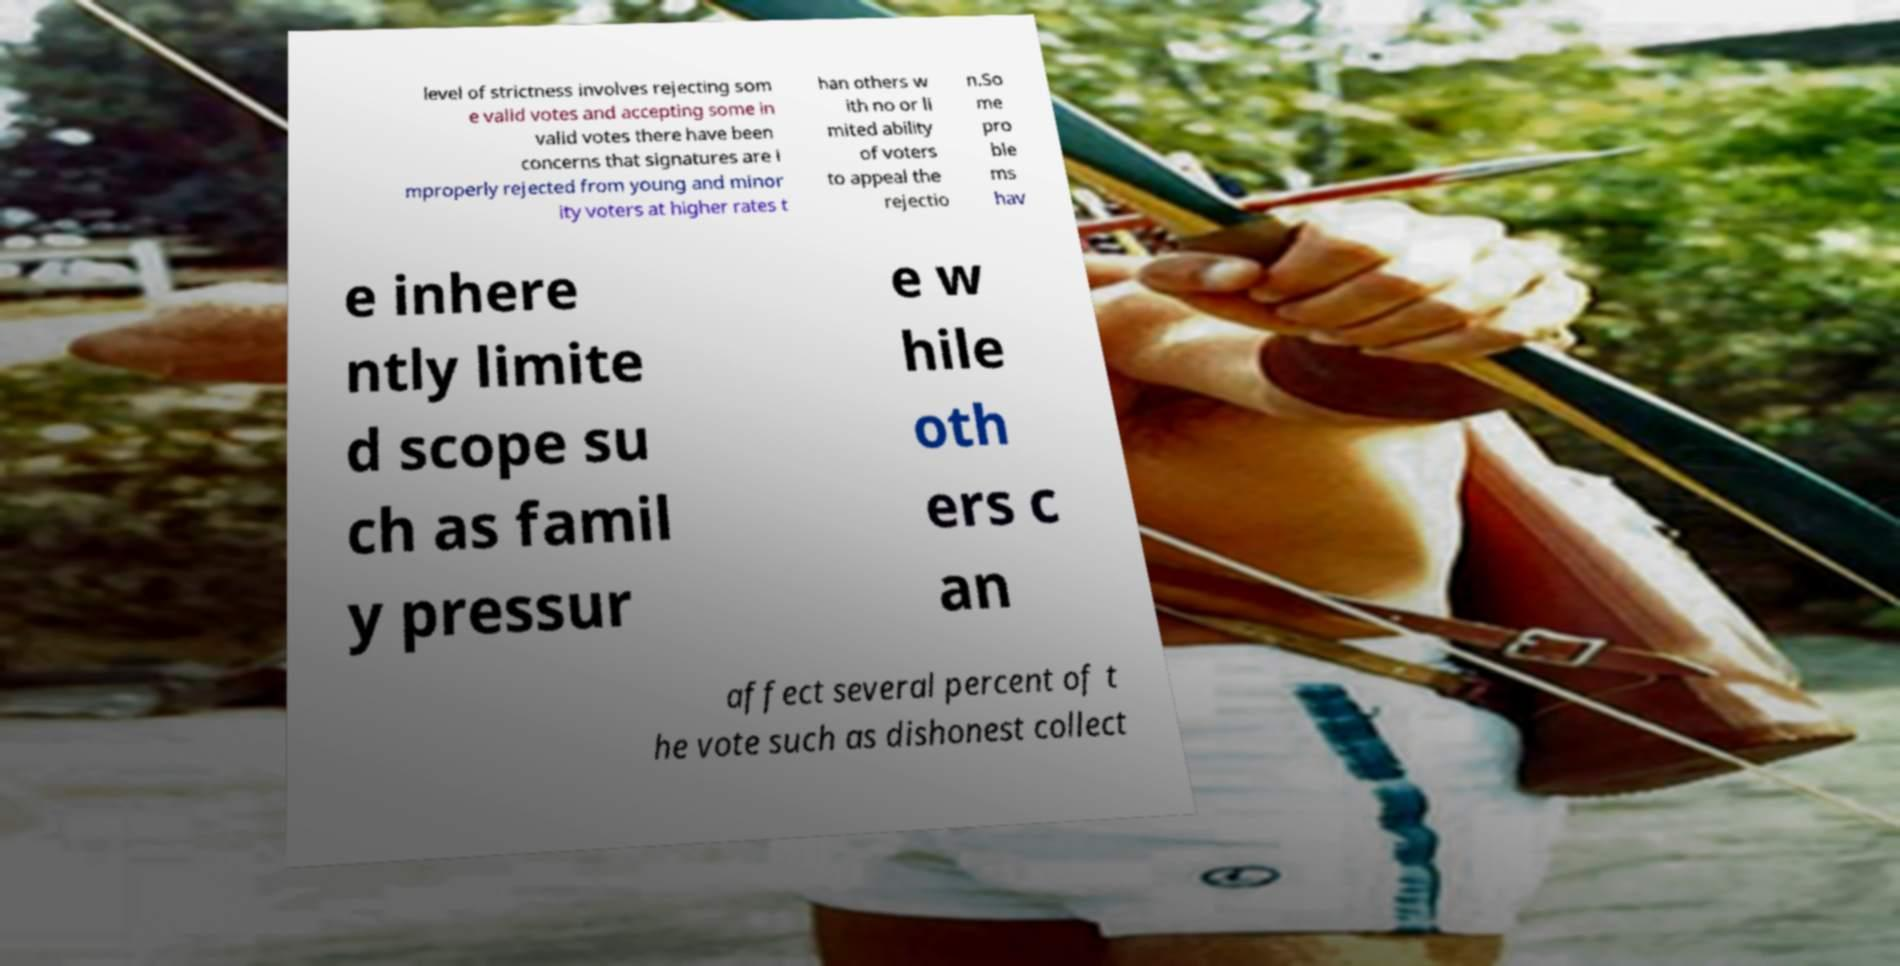Please identify and transcribe the text found in this image. level of strictness involves rejecting som e valid votes and accepting some in valid votes there have been concerns that signatures are i mproperly rejected from young and minor ity voters at higher rates t han others w ith no or li mited ability of voters to appeal the rejectio n.So me pro ble ms hav e inhere ntly limite d scope su ch as famil y pressur e w hile oth ers c an affect several percent of t he vote such as dishonest collect 